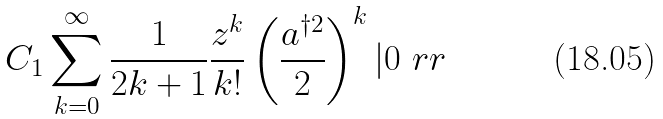Convert formula to latex. <formula><loc_0><loc_0><loc_500><loc_500>C _ { 1 } \sum _ { k = 0 } ^ { \infty } \frac { 1 } { 2 k + 1 } \frac { z ^ { k } } { k ! } \left ( \frac { a ^ { \dagger 2 } } { 2 } \right ) ^ { k } | 0 \ r r</formula> 